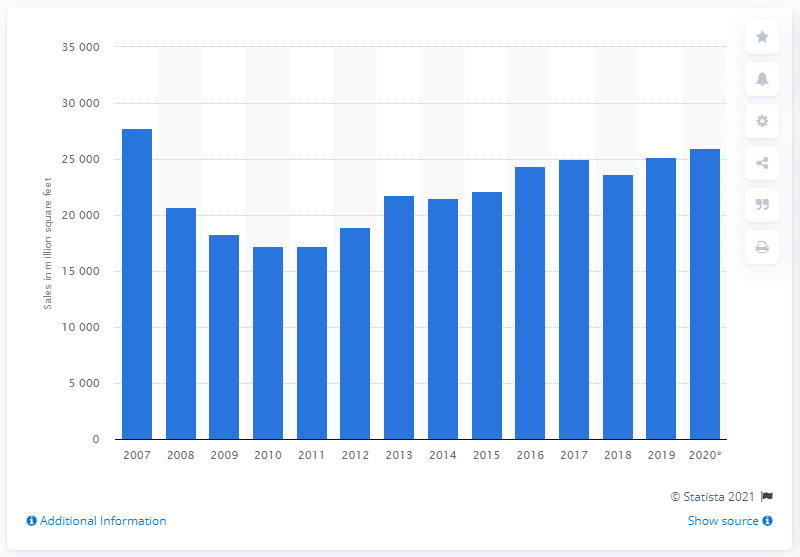Highlight a few significant elements in this photo. In 2020, approximately 26,000 square feet of wallboard products were sold in the United States. 